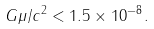<formula> <loc_0><loc_0><loc_500><loc_500>G \mu / c ^ { 2 } < 1 . 5 \times 1 0 ^ { - 8 } .</formula> 